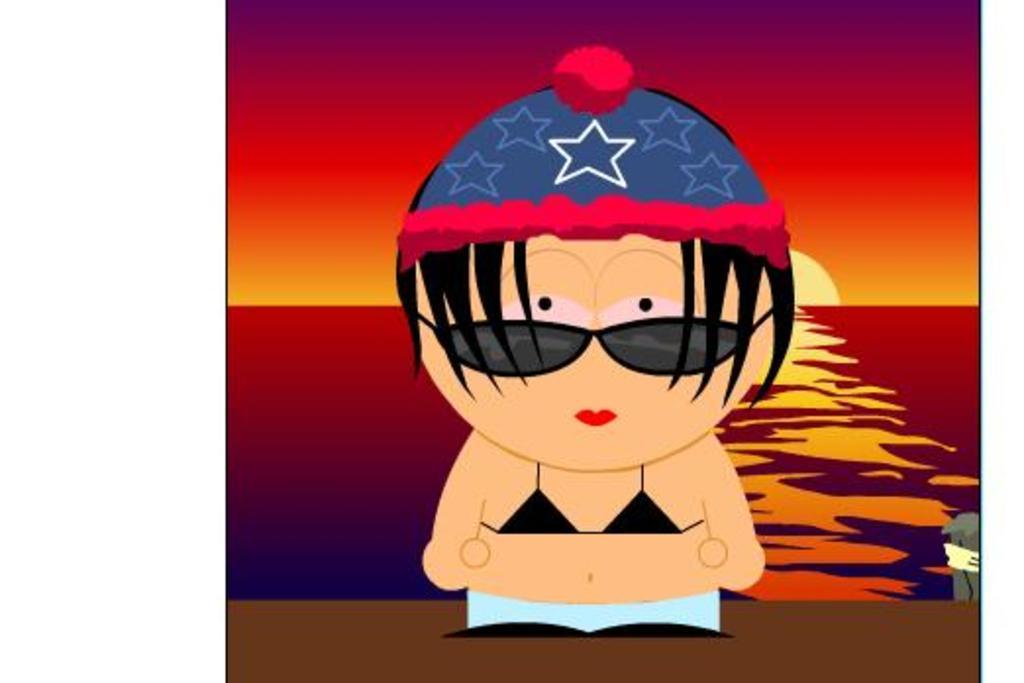Please provide a concise description of this image. This is an animated image. In this image we can see a woman. In the background of the image there is sky, sun and water. 